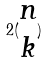Convert formula to latex. <formula><loc_0><loc_0><loc_500><loc_500>2 ( \begin{matrix} n \\ k \end{matrix} )</formula> 